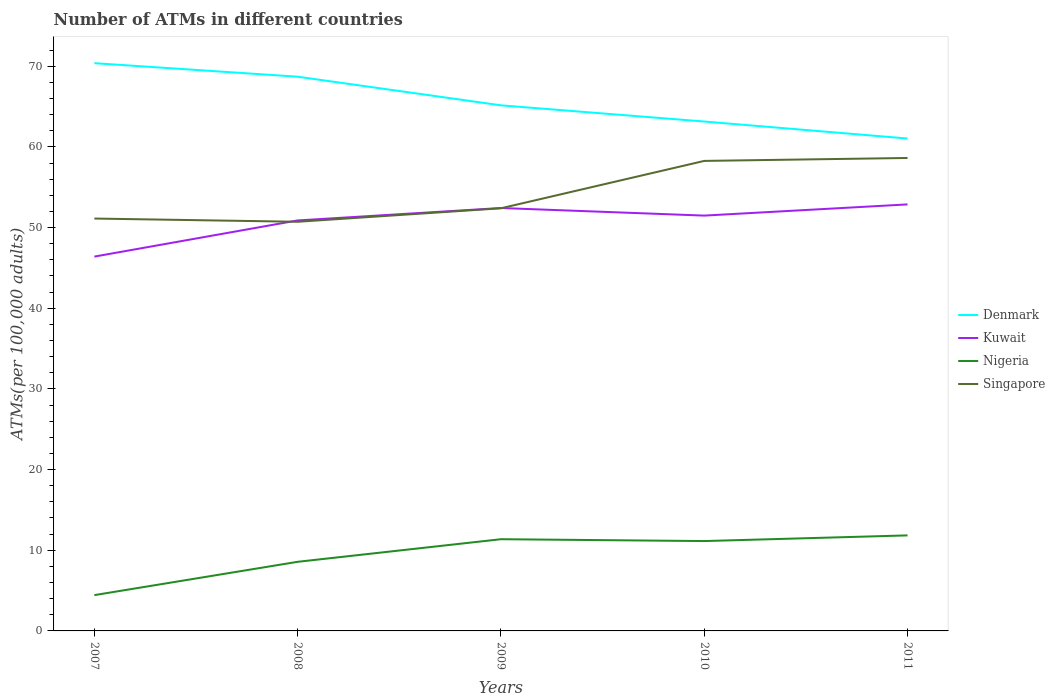Is the number of lines equal to the number of legend labels?
Your answer should be compact. Yes. Across all years, what is the maximum number of ATMs in Nigeria?
Provide a succinct answer. 4.44. In which year was the number of ATMs in Singapore maximum?
Give a very brief answer. 2008. What is the total number of ATMs in Denmark in the graph?
Your answer should be compact. 9.34. What is the difference between the highest and the second highest number of ATMs in Singapore?
Keep it short and to the point. 7.91. Is the number of ATMs in Kuwait strictly greater than the number of ATMs in Nigeria over the years?
Offer a terse response. No. How many lines are there?
Give a very brief answer. 4. How many years are there in the graph?
Your answer should be compact. 5. Are the values on the major ticks of Y-axis written in scientific E-notation?
Offer a very short reply. No. Does the graph contain any zero values?
Give a very brief answer. No. How are the legend labels stacked?
Make the answer very short. Vertical. What is the title of the graph?
Keep it short and to the point. Number of ATMs in different countries. Does "Mozambique" appear as one of the legend labels in the graph?
Offer a very short reply. No. What is the label or title of the X-axis?
Keep it short and to the point. Years. What is the label or title of the Y-axis?
Provide a succinct answer. ATMs(per 100,0 adults). What is the ATMs(per 100,000 adults) in Denmark in 2007?
Provide a succinct answer. 70.38. What is the ATMs(per 100,000 adults) in Kuwait in 2007?
Ensure brevity in your answer.  46.4. What is the ATMs(per 100,000 adults) of Nigeria in 2007?
Offer a very short reply. 4.44. What is the ATMs(per 100,000 adults) of Singapore in 2007?
Provide a succinct answer. 51.12. What is the ATMs(per 100,000 adults) in Denmark in 2008?
Offer a terse response. 68.71. What is the ATMs(per 100,000 adults) in Kuwait in 2008?
Make the answer very short. 50.89. What is the ATMs(per 100,000 adults) in Nigeria in 2008?
Your answer should be very brief. 8.57. What is the ATMs(per 100,000 adults) in Singapore in 2008?
Give a very brief answer. 50.72. What is the ATMs(per 100,000 adults) of Denmark in 2009?
Make the answer very short. 65.16. What is the ATMs(per 100,000 adults) in Kuwait in 2009?
Keep it short and to the point. 52.43. What is the ATMs(per 100,000 adults) in Nigeria in 2009?
Give a very brief answer. 11.37. What is the ATMs(per 100,000 adults) in Singapore in 2009?
Keep it short and to the point. 52.39. What is the ATMs(per 100,000 adults) in Denmark in 2010?
Your response must be concise. 63.15. What is the ATMs(per 100,000 adults) in Kuwait in 2010?
Give a very brief answer. 51.49. What is the ATMs(per 100,000 adults) in Nigeria in 2010?
Provide a short and direct response. 11.14. What is the ATMs(per 100,000 adults) of Singapore in 2010?
Offer a very short reply. 58.27. What is the ATMs(per 100,000 adults) of Denmark in 2011?
Make the answer very short. 61.04. What is the ATMs(per 100,000 adults) in Kuwait in 2011?
Provide a succinct answer. 52.87. What is the ATMs(per 100,000 adults) in Nigeria in 2011?
Keep it short and to the point. 11.84. What is the ATMs(per 100,000 adults) of Singapore in 2011?
Provide a succinct answer. 58.63. Across all years, what is the maximum ATMs(per 100,000 adults) of Denmark?
Your answer should be very brief. 70.38. Across all years, what is the maximum ATMs(per 100,000 adults) in Kuwait?
Offer a terse response. 52.87. Across all years, what is the maximum ATMs(per 100,000 adults) in Nigeria?
Give a very brief answer. 11.84. Across all years, what is the maximum ATMs(per 100,000 adults) of Singapore?
Provide a short and direct response. 58.63. Across all years, what is the minimum ATMs(per 100,000 adults) of Denmark?
Offer a terse response. 61.04. Across all years, what is the minimum ATMs(per 100,000 adults) in Kuwait?
Offer a very short reply. 46.4. Across all years, what is the minimum ATMs(per 100,000 adults) in Nigeria?
Give a very brief answer. 4.44. Across all years, what is the minimum ATMs(per 100,000 adults) in Singapore?
Provide a succinct answer. 50.72. What is the total ATMs(per 100,000 adults) of Denmark in the graph?
Provide a short and direct response. 328.43. What is the total ATMs(per 100,000 adults) of Kuwait in the graph?
Your answer should be very brief. 254.08. What is the total ATMs(per 100,000 adults) of Nigeria in the graph?
Ensure brevity in your answer.  47.36. What is the total ATMs(per 100,000 adults) in Singapore in the graph?
Give a very brief answer. 271.13. What is the difference between the ATMs(per 100,000 adults) in Denmark in 2007 and that in 2008?
Offer a terse response. 1.68. What is the difference between the ATMs(per 100,000 adults) of Kuwait in 2007 and that in 2008?
Keep it short and to the point. -4.48. What is the difference between the ATMs(per 100,000 adults) of Nigeria in 2007 and that in 2008?
Ensure brevity in your answer.  -4.13. What is the difference between the ATMs(per 100,000 adults) of Singapore in 2007 and that in 2008?
Your answer should be compact. 0.4. What is the difference between the ATMs(per 100,000 adults) of Denmark in 2007 and that in 2009?
Your answer should be compact. 5.23. What is the difference between the ATMs(per 100,000 adults) in Kuwait in 2007 and that in 2009?
Your response must be concise. -6.02. What is the difference between the ATMs(per 100,000 adults) in Nigeria in 2007 and that in 2009?
Your response must be concise. -6.93. What is the difference between the ATMs(per 100,000 adults) of Singapore in 2007 and that in 2009?
Your answer should be compact. -1.27. What is the difference between the ATMs(per 100,000 adults) of Denmark in 2007 and that in 2010?
Ensure brevity in your answer.  7.23. What is the difference between the ATMs(per 100,000 adults) of Kuwait in 2007 and that in 2010?
Offer a terse response. -5.08. What is the difference between the ATMs(per 100,000 adults) in Nigeria in 2007 and that in 2010?
Your answer should be very brief. -6.7. What is the difference between the ATMs(per 100,000 adults) in Singapore in 2007 and that in 2010?
Offer a very short reply. -7.14. What is the difference between the ATMs(per 100,000 adults) in Denmark in 2007 and that in 2011?
Ensure brevity in your answer.  9.34. What is the difference between the ATMs(per 100,000 adults) of Kuwait in 2007 and that in 2011?
Your answer should be compact. -6.47. What is the difference between the ATMs(per 100,000 adults) of Nigeria in 2007 and that in 2011?
Your response must be concise. -7.41. What is the difference between the ATMs(per 100,000 adults) in Singapore in 2007 and that in 2011?
Provide a short and direct response. -7.51. What is the difference between the ATMs(per 100,000 adults) of Denmark in 2008 and that in 2009?
Offer a terse response. 3.55. What is the difference between the ATMs(per 100,000 adults) in Kuwait in 2008 and that in 2009?
Offer a terse response. -1.54. What is the difference between the ATMs(per 100,000 adults) of Nigeria in 2008 and that in 2009?
Give a very brief answer. -2.8. What is the difference between the ATMs(per 100,000 adults) of Singapore in 2008 and that in 2009?
Give a very brief answer. -1.67. What is the difference between the ATMs(per 100,000 adults) of Denmark in 2008 and that in 2010?
Provide a succinct answer. 5.56. What is the difference between the ATMs(per 100,000 adults) of Kuwait in 2008 and that in 2010?
Your response must be concise. -0.6. What is the difference between the ATMs(per 100,000 adults) of Nigeria in 2008 and that in 2010?
Your response must be concise. -2.57. What is the difference between the ATMs(per 100,000 adults) in Singapore in 2008 and that in 2010?
Your answer should be compact. -7.54. What is the difference between the ATMs(per 100,000 adults) in Denmark in 2008 and that in 2011?
Your answer should be very brief. 7.66. What is the difference between the ATMs(per 100,000 adults) in Kuwait in 2008 and that in 2011?
Keep it short and to the point. -1.99. What is the difference between the ATMs(per 100,000 adults) of Nigeria in 2008 and that in 2011?
Make the answer very short. -3.28. What is the difference between the ATMs(per 100,000 adults) in Singapore in 2008 and that in 2011?
Offer a very short reply. -7.91. What is the difference between the ATMs(per 100,000 adults) of Denmark in 2009 and that in 2010?
Provide a succinct answer. 2.01. What is the difference between the ATMs(per 100,000 adults) in Kuwait in 2009 and that in 2010?
Offer a terse response. 0.94. What is the difference between the ATMs(per 100,000 adults) in Nigeria in 2009 and that in 2010?
Offer a very short reply. 0.23. What is the difference between the ATMs(per 100,000 adults) in Singapore in 2009 and that in 2010?
Your answer should be compact. -5.87. What is the difference between the ATMs(per 100,000 adults) of Denmark in 2009 and that in 2011?
Offer a terse response. 4.11. What is the difference between the ATMs(per 100,000 adults) in Kuwait in 2009 and that in 2011?
Provide a short and direct response. -0.45. What is the difference between the ATMs(per 100,000 adults) in Nigeria in 2009 and that in 2011?
Make the answer very short. -0.47. What is the difference between the ATMs(per 100,000 adults) in Singapore in 2009 and that in 2011?
Your answer should be very brief. -6.24. What is the difference between the ATMs(per 100,000 adults) in Denmark in 2010 and that in 2011?
Provide a short and direct response. 2.11. What is the difference between the ATMs(per 100,000 adults) in Kuwait in 2010 and that in 2011?
Provide a short and direct response. -1.39. What is the difference between the ATMs(per 100,000 adults) of Nigeria in 2010 and that in 2011?
Give a very brief answer. -0.7. What is the difference between the ATMs(per 100,000 adults) of Singapore in 2010 and that in 2011?
Keep it short and to the point. -0.36. What is the difference between the ATMs(per 100,000 adults) of Denmark in 2007 and the ATMs(per 100,000 adults) of Kuwait in 2008?
Keep it short and to the point. 19.49. What is the difference between the ATMs(per 100,000 adults) of Denmark in 2007 and the ATMs(per 100,000 adults) of Nigeria in 2008?
Ensure brevity in your answer.  61.81. What is the difference between the ATMs(per 100,000 adults) of Denmark in 2007 and the ATMs(per 100,000 adults) of Singapore in 2008?
Offer a very short reply. 19.66. What is the difference between the ATMs(per 100,000 adults) of Kuwait in 2007 and the ATMs(per 100,000 adults) of Nigeria in 2008?
Offer a terse response. 37.84. What is the difference between the ATMs(per 100,000 adults) of Kuwait in 2007 and the ATMs(per 100,000 adults) of Singapore in 2008?
Keep it short and to the point. -4.32. What is the difference between the ATMs(per 100,000 adults) of Nigeria in 2007 and the ATMs(per 100,000 adults) of Singapore in 2008?
Keep it short and to the point. -46.28. What is the difference between the ATMs(per 100,000 adults) in Denmark in 2007 and the ATMs(per 100,000 adults) in Kuwait in 2009?
Your answer should be very brief. 17.96. What is the difference between the ATMs(per 100,000 adults) in Denmark in 2007 and the ATMs(per 100,000 adults) in Nigeria in 2009?
Keep it short and to the point. 59.01. What is the difference between the ATMs(per 100,000 adults) in Denmark in 2007 and the ATMs(per 100,000 adults) in Singapore in 2009?
Provide a succinct answer. 17.99. What is the difference between the ATMs(per 100,000 adults) of Kuwait in 2007 and the ATMs(per 100,000 adults) of Nigeria in 2009?
Keep it short and to the point. 35.04. What is the difference between the ATMs(per 100,000 adults) of Kuwait in 2007 and the ATMs(per 100,000 adults) of Singapore in 2009?
Your answer should be very brief. -5.99. What is the difference between the ATMs(per 100,000 adults) in Nigeria in 2007 and the ATMs(per 100,000 adults) in Singapore in 2009?
Provide a succinct answer. -47.96. What is the difference between the ATMs(per 100,000 adults) in Denmark in 2007 and the ATMs(per 100,000 adults) in Kuwait in 2010?
Make the answer very short. 18.9. What is the difference between the ATMs(per 100,000 adults) of Denmark in 2007 and the ATMs(per 100,000 adults) of Nigeria in 2010?
Your answer should be compact. 59.24. What is the difference between the ATMs(per 100,000 adults) in Denmark in 2007 and the ATMs(per 100,000 adults) in Singapore in 2010?
Make the answer very short. 12.12. What is the difference between the ATMs(per 100,000 adults) of Kuwait in 2007 and the ATMs(per 100,000 adults) of Nigeria in 2010?
Keep it short and to the point. 35.27. What is the difference between the ATMs(per 100,000 adults) in Kuwait in 2007 and the ATMs(per 100,000 adults) in Singapore in 2010?
Your response must be concise. -11.86. What is the difference between the ATMs(per 100,000 adults) of Nigeria in 2007 and the ATMs(per 100,000 adults) of Singapore in 2010?
Your response must be concise. -53.83. What is the difference between the ATMs(per 100,000 adults) in Denmark in 2007 and the ATMs(per 100,000 adults) in Kuwait in 2011?
Make the answer very short. 17.51. What is the difference between the ATMs(per 100,000 adults) of Denmark in 2007 and the ATMs(per 100,000 adults) of Nigeria in 2011?
Offer a very short reply. 58.54. What is the difference between the ATMs(per 100,000 adults) of Denmark in 2007 and the ATMs(per 100,000 adults) of Singapore in 2011?
Keep it short and to the point. 11.75. What is the difference between the ATMs(per 100,000 adults) in Kuwait in 2007 and the ATMs(per 100,000 adults) in Nigeria in 2011?
Your answer should be very brief. 34.56. What is the difference between the ATMs(per 100,000 adults) in Kuwait in 2007 and the ATMs(per 100,000 adults) in Singapore in 2011?
Offer a very short reply. -12.23. What is the difference between the ATMs(per 100,000 adults) of Nigeria in 2007 and the ATMs(per 100,000 adults) of Singapore in 2011?
Offer a very short reply. -54.19. What is the difference between the ATMs(per 100,000 adults) of Denmark in 2008 and the ATMs(per 100,000 adults) of Kuwait in 2009?
Provide a succinct answer. 16.28. What is the difference between the ATMs(per 100,000 adults) of Denmark in 2008 and the ATMs(per 100,000 adults) of Nigeria in 2009?
Your answer should be compact. 57.34. What is the difference between the ATMs(per 100,000 adults) in Denmark in 2008 and the ATMs(per 100,000 adults) in Singapore in 2009?
Your answer should be very brief. 16.31. What is the difference between the ATMs(per 100,000 adults) in Kuwait in 2008 and the ATMs(per 100,000 adults) in Nigeria in 2009?
Offer a very short reply. 39.52. What is the difference between the ATMs(per 100,000 adults) in Kuwait in 2008 and the ATMs(per 100,000 adults) in Singapore in 2009?
Your answer should be compact. -1.51. What is the difference between the ATMs(per 100,000 adults) in Nigeria in 2008 and the ATMs(per 100,000 adults) in Singapore in 2009?
Keep it short and to the point. -43.83. What is the difference between the ATMs(per 100,000 adults) in Denmark in 2008 and the ATMs(per 100,000 adults) in Kuwait in 2010?
Provide a succinct answer. 17.22. What is the difference between the ATMs(per 100,000 adults) of Denmark in 2008 and the ATMs(per 100,000 adults) of Nigeria in 2010?
Provide a short and direct response. 57.57. What is the difference between the ATMs(per 100,000 adults) of Denmark in 2008 and the ATMs(per 100,000 adults) of Singapore in 2010?
Make the answer very short. 10.44. What is the difference between the ATMs(per 100,000 adults) in Kuwait in 2008 and the ATMs(per 100,000 adults) in Nigeria in 2010?
Give a very brief answer. 39.75. What is the difference between the ATMs(per 100,000 adults) of Kuwait in 2008 and the ATMs(per 100,000 adults) of Singapore in 2010?
Ensure brevity in your answer.  -7.38. What is the difference between the ATMs(per 100,000 adults) of Nigeria in 2008 and the ATMs(per 100,000 adults) of Singapore in 2010?
Keep it short and to the point. -49.7. What is the difference between the ATMs(per 100,000 adults) in Denmark in 2008 and the ATMs(per 100,000 adults) in Kuwait in 2011?
Your answer should be compact. 15.83. What is the difference between the ATMs(per 100,000 adults) of Denmark in 2008 and the ATMs(per 100,000 adults) of Nigeria in 2011?
Give a very brief answer. 56.86. What is the difference between the ATMs(per 100,000 adults) in Denmark in 2008 and the ATMs(per 100,000 adults) in Singapore in 2011?
Provide a short and direct response. 10.08. What is the difference between the ATMs(per 100,000 adults) of Kuwait in 2008 and the ATMs(per 100,000 adults) of Nigeria in 2011?
Your answer should be compact. 39.04. What is the difference between the ATMs(per 100,000 adults) in Kuwait in 2008 and the ATMs(per 100,000 adults) in Singapore in 2011?
Your answer should be very brief. -7.74. What is the difference between the ATMs(per 100,000 adults) in Nigeria in 2008 and the ATMs(per 100,000 adults) in Singapore in 2011?
Provide a succinct answer. -50.06. What is the difference between the ATMs(per 100,000 adults) of Denmark in 2009 and the ATMs(per 100,000 adults) of Kuwait in 2010?
Provide a short and direct response. 13.67. What is the difference between the ATMs(per 100,000 adults) in Denmark in 2009 and the ATMs(per 100,000 adults) in Nigeria in 2010?
Ensure brevity in your answer.  54.02. What is the difference between the ATMs(per 100,000 adults) of Denmark in 2009 and the ATMs(per 100,000 adults) of Singapore in 2010?
Offer a very short reply. 6.89. What is the difference between the ATMs(per 100,000 adults) in Kuwait in 2009 and the ATMs(per 100,000 adults) in Nigeria in 2010?
Ensure brevity in your answer.  41.29. What is the difference between the ATMs(per 100,000 adults) in Kuwait in 2009 and the ATMs(per 100,000 adults) in Singapore in 2010?
Your response must be concise. -5.84. What is the difference between the ATMs(per 100,000 adults) of Nigeria in 2009 and the ATMs(per 100,000 adults) of Singapore in 2010?
Provide a succinct answer. -46.9. What is the difference between the ATMs(per 100,000 adults) in Denmark in 2009 and the ATMs(per 100,000 adults) in Kuwait in 2011?
Offer a very short reply. 12.28. What is the difference between the ATMs(per 100,000 adults) of Denmark in 2009 and the ATMs(per 100,000 adults) of Nigeria in 2011?
Provide a short and direct response. 53.31. What is the difference between the ATMs(per 100,000 adults) of Denmark in 2009 and the ATMs(per 100,000 adults) of Singapore in 2011?
Give a very brief answer. 6.53. What is the difference between the ATMs(per 100,000 adults) of Kuwait in 2009 and the ATMs(per 100,000 adults) of Nigeria in 2011?
Make the answer very short. 40.58. What is the difference between the ATMs(per 100,000 adults) in Kuwait in 2009 and the ATMs(per 100,000 adults) in Singapore in 2011?
Provide a succinct answer. -6.2. What is the difference between the ATMs(per 100,000 adults) of Nigeria in 2009 and the ATMs(per 100,000 adults) of Singapore in 2011?
Offer a very short reply. -47.26. What is the difference between the ATMs(per 100,000 adults) of Denmark in 2010 and the ATMs(per 100,000 adults) of Kuwait in 2011?
Give a very brief answer. 10.27. What is the difference between the ATMs(per 100,000 adults) in Denmark in 2010 and the ATMs(per 100,000 adults) in Nigeria in 2011?
Your response must be concise. 51.31. What is the difference between the ATMs(per 100,000 adults) in Denmark in 2010 and the ATMs(per 100,000 adults) in Singapore in 2011?
Provide a short and direct response. 4.52. What is the difference between the ATMs(per 100,000 adults) of Kuwait in 2010 and the ATMs(per 100,000 adults) of Nigeria in 2011?
Provide a succinct answer. 39.64. What is the difference between the ATMs(per 100,000 adults) in Kuwait in 2010 and the ATMs(per 100,000 adults) in Singapore in 2011?
Your answer should be compact. -7.14. What is the difference between the ATMs(per 100,000 adults) of Nigeria in 2010 and the ATMs(per 100,000 adults) of Singapore in 2011?
Make the answer very short. -47.49. What is the average ATMs(per 100,000 adults) in Denmark per year?
Keep it short and to the point. 65.69. What is the average ATMs(per 100,000 adults) of Kuwait per year?
Provide a short and direct response. 50.82. What is the average ATMs(per 100,000 adults) of Nigeria per year?
Keep it short and to the point. 9.47. What is the average ATMs(per 100,000 adults) in Singapore per year?
Ensure brevity in your answer.  54.23. In the year 2007, what is the difference between the ATMs(per 100,000 adults) of Denmark and ATMs(per 100,000 adults) of Kuwait?
Ensure brevity in your answer.  23.98. In the year 2007, what is the difference between the ATMs(per 100,000 adults) of Denmark and ATMs(per 100,000 adults) of Nigeria?
Ensure brevity in your answer.  65.94. In the year 2007, what is the difference between the ATMs(per 100,000 adults) of Denmark and ATMs(per 100,000 adults) of Singapore?
Offer a terse response. 19.26. In the year 2007, what is the difference between the ATMs(per 100,000 adults) in Kuwait and ATMs(per 100,000 adults) in Nigeria?
Ensure brevity in your answer.  41.97. In the year 2007, what is the difference between the ATMs(per 100,000 adults) in Kuwait and ATMs(per 100,000 adults) in Singapore?
Provide a short and direct response. -4.72. In the year 2007, what is the difference between the ATMs(per 100,000 adults) of Nigeria and ATMs(per 100,000 adults) of Singapore?
Your answer should be compact. -46.68. In the year 2008, what is the difference between the ATMs(per 100,000 adults) of Denmark and ATMs(per 100,000 adults) of Kuwait?
Your answer should be very brief. 17.82. In the year 2008, what is the difference between the ATMs(per 100,000 adults) in Denmark and ATMs(per 100,000 adults) in Nigeria?
Offer a terse response. 60.14. In the year 2008, what is the difference between the ATMs(per 100,000 adults) in Denmark and ATMs(per 100,000 adults) in Singapore?
Provide a succinct answer. 17.98. In the year 2008, what is the difference between the ATMs(per 100,000 adults) of Kuwait and ATMs(per 100,000 adults) of Nigeria?
Provide a short and direct response. 42.32. In the year 2008, what is the difference between the ATMs(per 100,000 adults) of Kuwait and ATMs(per 100,000 adults) of Singapore?
Offer a very short reply. 0.17. In the year 2008, what is the difference between the ATMs(per 100,000 adults) in Nigeria and ATMs(per 100,000 adults) in Singapore?
Ensure brevity in your answer.  -42.15. In the year 2009, what is the difference between the ATMs(per 100,000 adults) in Denmark and ATMs(per 100,000 adults) in Kuwait?
Your response must be concise. 12.73. In the year 2009, what is the difference between the ATMs(per 100,000 adults) of Denmark and ATMs(per 100,000 adults) of Nigeria?
Keep it short and to the point. 53.79. In the year 2009, what is the difference between the ATMs(per 100,000 adults) in Denmark and ATMs(per 100,000 adults) in Singapore?
Keep it short and to the point. 12.76. In the year 2009, what is the difference between the ATMs(per 100,000 adults) in Kuwait and ATMs(per 100,000 adults) in Nigeria?
Your answer should be very brief. 41.06. In the year 2009, what is the difference between the ATMs(per 100,000 adults) in Kuwait and ATMs(per 100,000 adults) in Singapore?
Your answer should be very brief. 0.03. In the year 2009, what is the difference between the ATMs(per 100,000 adults) in Nigeria and ATMs(per 100,000 adults) in Singapore?
Keep it short and to the point. -41.02. In the year 2010, what is the difference between the ATMs(per 100,000 adults) in Denmark and ATMs(per 100,000 adults) in Kuwait?
Make the answer very short. 11.66. In the year 2010, what is the difference between the ATMs(per 100,000 adults) of Denmark and ATMs(per 100,000 adults) of Nigeria?
Offer a terse response. 52.01. In the year 2010, what is the difference between the ATMs(per 100,000 adults) of Denmark and ATMs(per 100,000 adults) of Singapore?
Give a very brief answer. 4.88. In the year 2010, what is the difference between the ATMs(per 100,000 adults) in Kuwait and ATMs(per 100,000 adults) in Nigeria?
Offer a very short reply. 40.35. In the year 2010, what is the difference between the ATMs(per 100,000 adults) in Kuwait and ATMs(per 100,000 adults) in Singapore?
Make the answer very short. -6.78. In the year 2010, what is the difference between the ATMs(per 100,000 adults) of Nigeria and ATMs(per 100,000 adults) of Singapore?
Make the answer very short. -47.13. In the year 2011, what is the difference between the ATMs(per 100,000 adults) in Denmark and ATMs(per 100,000 adults) in Kuwait?
Your answer should be very brief. 8.17. In the year 2011, what is the difference between the ATMs(per 100,000 adults) in Denmark and ATMs(per 100,000 adults) in Nigeria?
Your response must be concise. 49.2. In the year 2011, what is the difference between the ATMs(per 100,000 adults) in Denmark and ATMs(per 100,000 adults) in Singapore?
Provide a short and direct response. 2.41. In the year 2011, what is the difference between the ATMs(per 100,000 adults) of Kuwait and ATMs(per 100,000 adults) of Nigeria?
Make the answer very short. 41.03. In the year 2011, what is the difference between the ATMs(per 100,000 adults) of Kuwait and ATMs(per 100,000 adults) of Singapore?
Provide a short and direct response. -5.76. In the year 2011, what is the difference between the ATMs(per 100,000 adults) in Nigeria and ATMs(per 100,000 adults) in Singapore?
Provide a short and direct response. -46.79. What is the ratio of the ATMs(per 100,000 adults) in Denmark in 2007 to that in 2008?
Your answer should be very brief. 1.02. What is the ratio of the ATMs(per 100,000 adults) of Kuwait in 2007 to that in 2008?
Offer a terse response. 0.91. What is the ratio of the ATMs(per 100,000 adults) in Nigeria in 2007 to that in 2008?
Ensure brevity in your answer.  0.52. What is the ratio of the ATMs(per 100,000 adults) in Singapore in 2007 to that in 2008?
Give a very brief answer. 1.01. What is the ratio of the ATMs(per 100,000 adults) in Denmark in 2007 to that in 2009?
Keep it short and to the point. 1.08. What is the ratio of the ATMs(per 100,000 adults) in Kuwait in 2007 to that in 2009?
Ensure brevity in your answer.  0.89. What is the ratio of the ATMs(per 100,000 adults) of Nigeria in 2007 to that in 2009?
Your answer should be compact. 0.39. What is the ratio of the ATMs(per 100,000 adults) in Singapore in 2007 to that in 2009?
Your response must be concise. 0.98. What is the ratio of the ATMs(per 100,000 adults) of Denmark in 2007 to that in 2010?
Your response must be concise. 1.11. What is the ratio of the ATMs(per 100,000 adults) in Kuwait in 2007 to that in 2010?
Your answer should be compact. 0.9. What is the ratio of the ATMs(per 100,000 adults) in Nigeria in 2007 to that in 2010?
Give a very brief answer. 0.4. What is the ratio of the ATMs(per 100,000 adults) of Singapore in 2007 to that in 2010?
Offer a terse response. 0.88. What is the ratio of the ATMs(per 100,000 adults) in Denmark in 2007 to that in 2011?
Offer a very short reply. 1.15. What is the ratio of the ATMs(per 100,000 adults) of Kuwait in 2007 to that in 2011?
Give a very brief answer. 0.88. What is the ratio of the ATMs(per 100,000 adults) in Nigeria in 2007 to that in 2011?
Offer a terse response. 0.37. What is the ratio of the ATMs(per 100,000 adults) in Singapore in 2007 to that in 2011?
Give a very brief answer. 0.87. What is the ratio of the ATMs(per 100,000 adults) of Denmark in 2008 to that in 2009?
Your answer should be compact. 1.05. What is the ratio of the ATMs(per 100,000 adults) in Kuwait in 2008 to that in 2009?
Your answer should be compact. 0.97. What is the ratio of the ATMs(per 100,000 adults) in Nigeria in 2008 to that in 2009?
Ensure brevity in your answer.  0.75. What is the ratio of the ATMs(per 100,000 adults) in Singapore in 2008 to that in 2009?
Your response must be concise. 0.97. What is the ratio of the ATMs(per 100,000 adults) in Denmark in 2008 to that in 2010?
Provide a succinct answer. 1.09. What is the ratio of the ATMs(per 100,000 adults) in Kuwait in 2008 to that in 2010?
Make the answer very short. 0.99. What is the ratio of the ATMs(per 100,000 adults) in Nigeria in 2008 to that in 2010?
Your response must be concise. 0.77. What is the ratio of the ATMs(per 100,000 adults) of Singapore in 2008 to that in 2010?
Your answer should be compact. 0.87. What is the ratio of the ATMs(per 100,000 adults) in Denmark in 2008 to that in 2011?
Provide a succinct answer. 1.13. What is the ratio of the ATMs(per 100,000 adults) in Kuwait in 2008 to that in 2011?
Offer a very short reply. 0.96. What is the ratio of the ATMs(per 100,000 adults) in Nigeria in 2008 to that in 2011?
Provide a short and direct response. 0.72. What is the ratio of the ATMs(per 100,000 adults) in Singapore in 2008 to that in 2011?
Your response must be concise. 0.87. What is the ratio of the ATMs(per 100,000 adults) of Denmark in 2009 to that in 2010?
Provide a short and direct response. 1.03. What is the ratio of the ATMs(per 100,000 adults) of Kuwait in 2009 to that in 2010?
Your answer should be very brief. 1.02. What is the ratio of the ATMs(per 100,000 adults) in Nigeria in 2009 to that in 2010?
Give a very brief answer. 1.02. What is the ratio of the ATMs(per 100,000 adults) in Singapore in 2009 to that in 2010?
Ensure brevity in your answer.  0.9. What is the ratio of the ATMs(per 100,000 adults) in Denmark in 2009 to that in 2011?
Give a very brief answer. 1.07. What is the ratio of the ATMs(per 100,000 adults) of Kuwait in 2009 to that in 2011?
Ensure brevity in your answer.  0.99. What is the ratio of the ATMs(per 100,000 adults) in Singapore in 2009 to that in 2011?
Keep it short and to the point. 0.89. What is the ratio of the ATMs(per 100,000 adults) of Denmark in 2010 to that in 2011?
Keep it short and to the point. 1.03. What is the ratio of the ATMs(per 100,000 adults) in Kuwait in 2010 to that in 2011?
Offer a very short reply. 0.97. What is the ratio of the ATMs(per 100,000 adults) in Nigeria in 2010 to that in 2011?
Provide a succinct answer. 0.94. What is the difference between the highest and the second highest ATMs(per 100,000 adults) in Denmark?
Offer a very short reply. 1.68. What is the difference between the highest and the second highest ATMs(per 100,000 adults) in Kuwait?
Ensure brevity in your answer.  0.45. What is the difference between the highest and the second highest ATMs(per 100,000 adults) in Nigeria?
Offer a terse response. 0.47. What is the difference between the highest and the second highest ATMs(per 100,000 adults) in Singapore?
Ensure brevity in your answer.  0.36. What is the difference between the highest and the lowest ATMs(per 100,000 adults) in Denmark?
Your response must be concise. 9.34. What is the difference between the highest and the lowest ATMs(per 100,000 adults) of Kuwait?
Make the answer very short. 6.47. What is the difference between the highest and the lowest ATMs(per 100,000 adults) of Nigeria?
Keep it short and to the point. 7.41. What is the difference between the highest and the lowest ATMs(per 100,000 adults) of Singapore?
Ensure brevity in your answer.  7.91. 